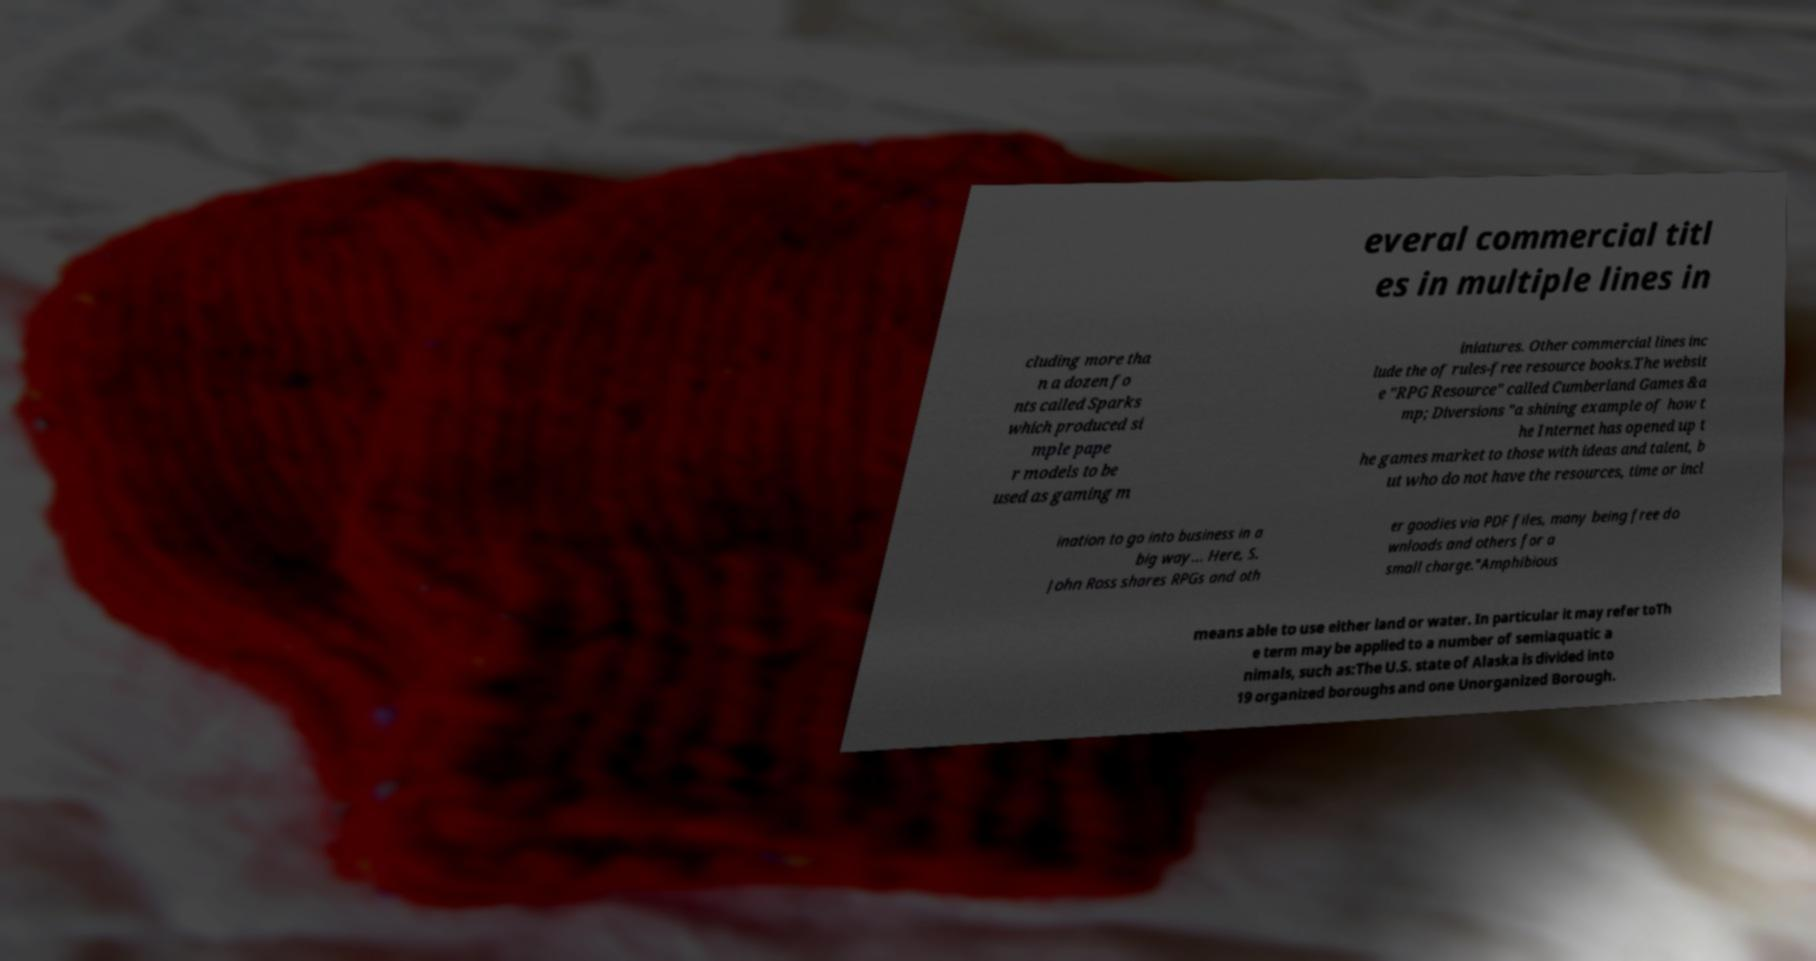Please read and relay the text visible in this image. What does it say? everal commercial titl es in multiple lines in cluding more tha n a dozen fo nts called Sparks which produced si mple pape r models to be used as gaming m iniatures. Other commercial lines inc lude the of rules-free resource books.The websit e "RPG Resource" called Cumberland Games &a mp; Diversions "a shining example of how t he Internet has opened up t he games market to those with ideas and talent, b ut who do not have the resources, time or incl ination to go into business in a big way... Here, S. John Ross shares RPGs and oth er goodies via PDF files, many being free do wnloads and others for a small charge."Amphibious means able to use either land or water. In particular it may refer toTh e term may be applied to a number of semiaquatic a nimals, such as:The U.S. state of Alaska is divided into 19 organized boroughs and one Unorganized Borough. 